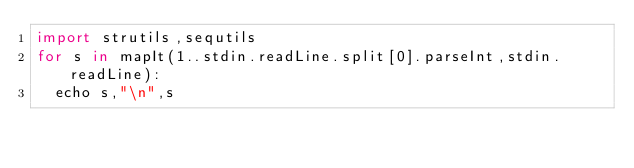Convert code to text. <code><loc_0><loc_0><loc_500><loc_500><_Nim_>import strutils,sequtils
for s in mapIt(1..stdin.readLine.split[0].parseInt,stdin.readLine):
  echo s,"\n",s</code> 